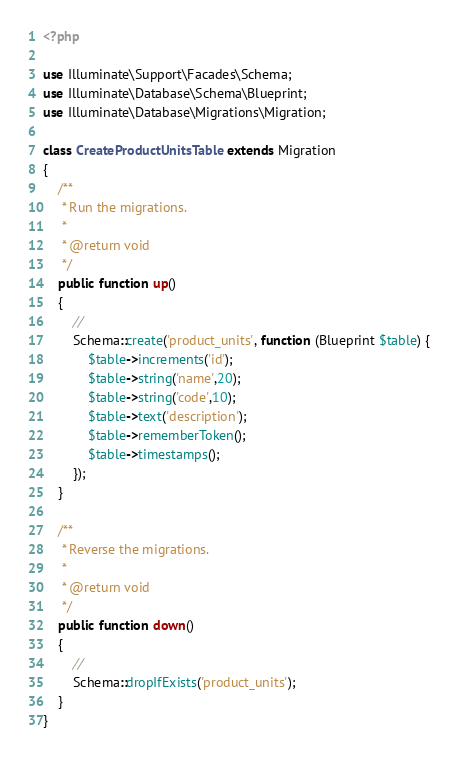<code> <loc_0><loc_0><loc_500><loc_500><_PHP_><?php

use Illuminate\Support\Facades\Schema;
use Illuminate\Database\Schema\Blueprint;
use Illuminate\Database\Migrations\Migration;

class CreateProductUnitsTable extends Migration
{
    /**
     * Run the migrations.
     *
     * @return void
     */
    public function up()
    {
        //
        Schema::create('product_units', function (Blueprint $table) {
            $table->increments('id');
            $table->string('name',20);
            $table->string('code',10);
            $table->text('description');
            $table->rememberToken();
            $table->timestamps();            
        });
    }

    /**
     * Reverse the migrations.
     *
     * @return void
     */
    public function down()
    {
        //
        Schema::dropIfExists('product_units');
    }
}
</code> 